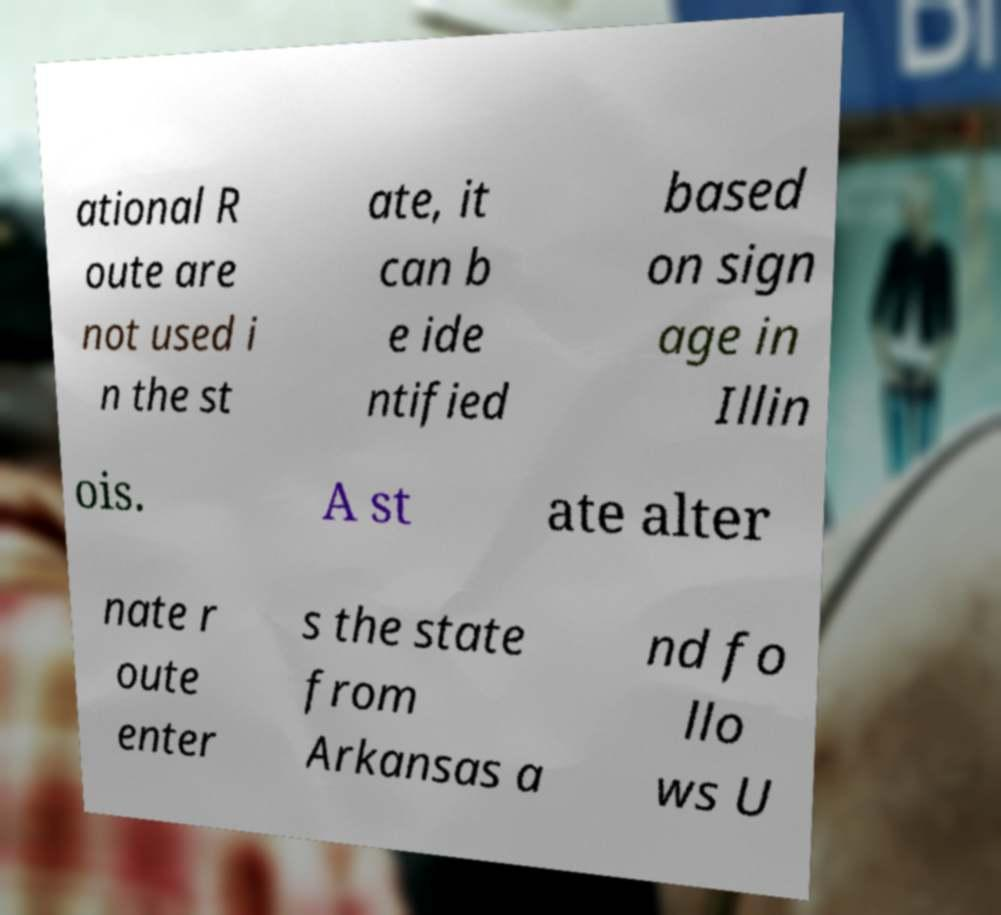I need the written content from this picture converted into text. Can you do that? ational R oute are not used i n the st ate, it can b e ide ntified based on sign age in Illin ois. A st ate alter nate r oute enter s the state from Arkansas a nd fo llo ws U 